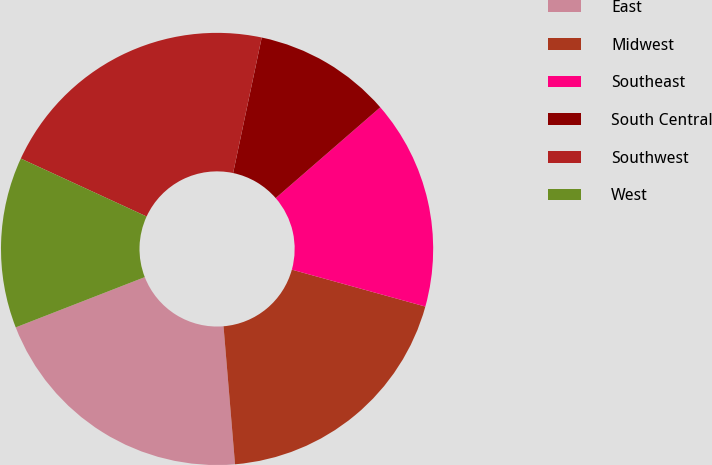Convert chart to OTSL. <chart><loc_0><loc_0><loc_500><loc_500><pie_chart><fcel>East<fcel>Midwest<fcel>Southeast<fcel>South Central<fcel>Southwest<fcel>West<nl><fcel>20.41%<fcel>19.38%<fcel>15.67%<fcel>10.31%<fcel>21.44%<fcel>12.78%<nl></chart> 